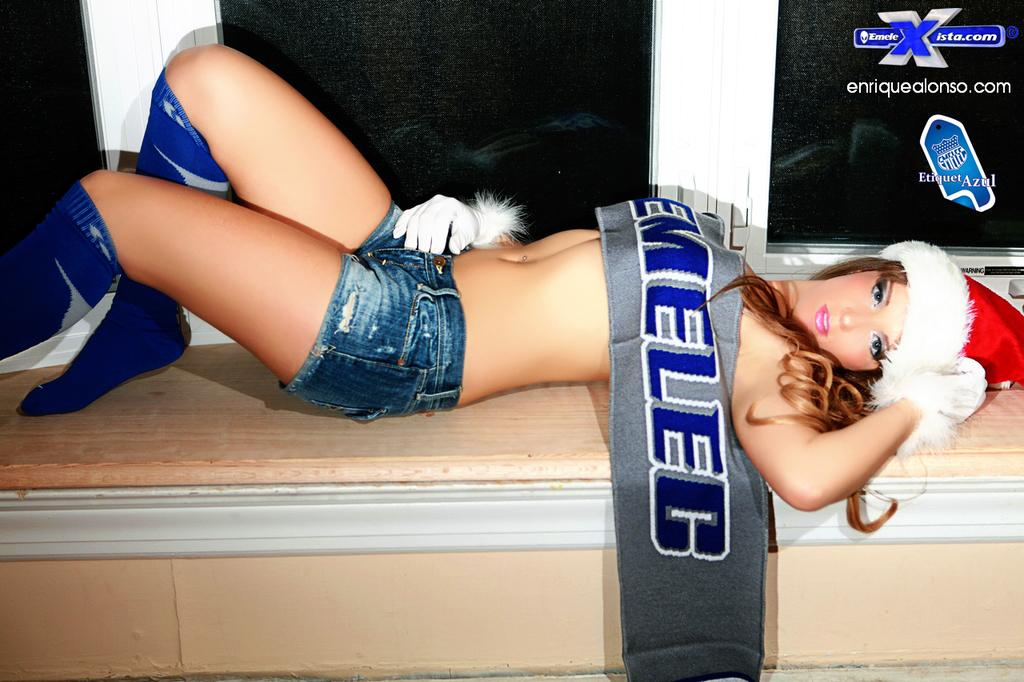Provide a one-sentence caption for the provided image. an enriquealonso ad next to a lady scantily clad. 